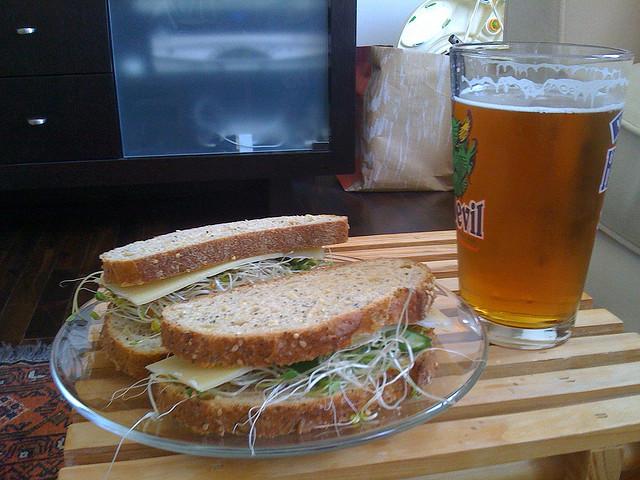What kind of beer is in the mug on the right?
Write a very short answer. Ale. What is the stringy stuff on the sandwich?
Short answer required. Sprouts. How many sandwiches?
Short answer required. 2. Is that a hot dog?
Write a very short answer. No. What is in the glass?
Short answer required. Beer. What beverage is in the glass?
Quick response, please. Beer. Is that a chili dog?
Answer briefly. No. 